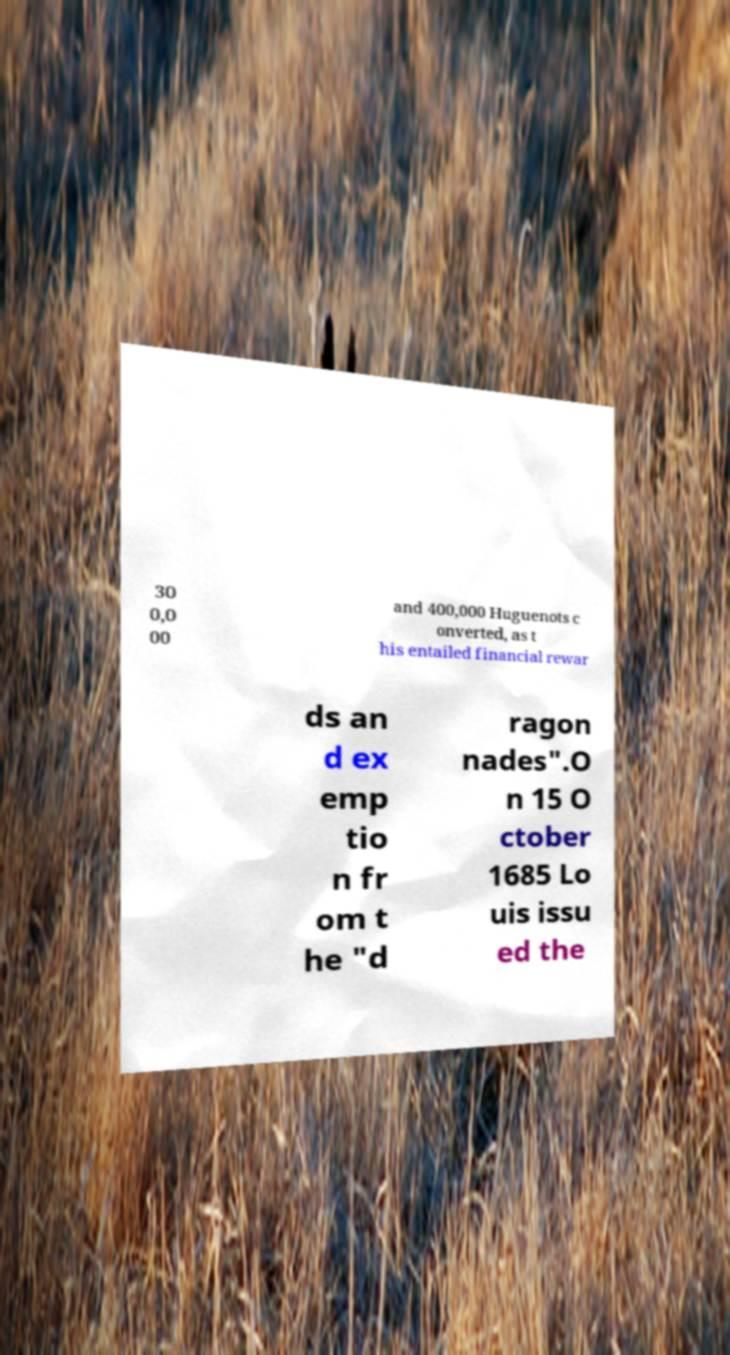Please read and relay the text visible in this image. What does it say? 30 0,0 00 and 400,000 Huguenots c onverted, as t his entailed financial rewar ds an d ex emp tio n fr om t he "d ragon nades".O n 15 O ctober 1685 Lo uis issu ed the 